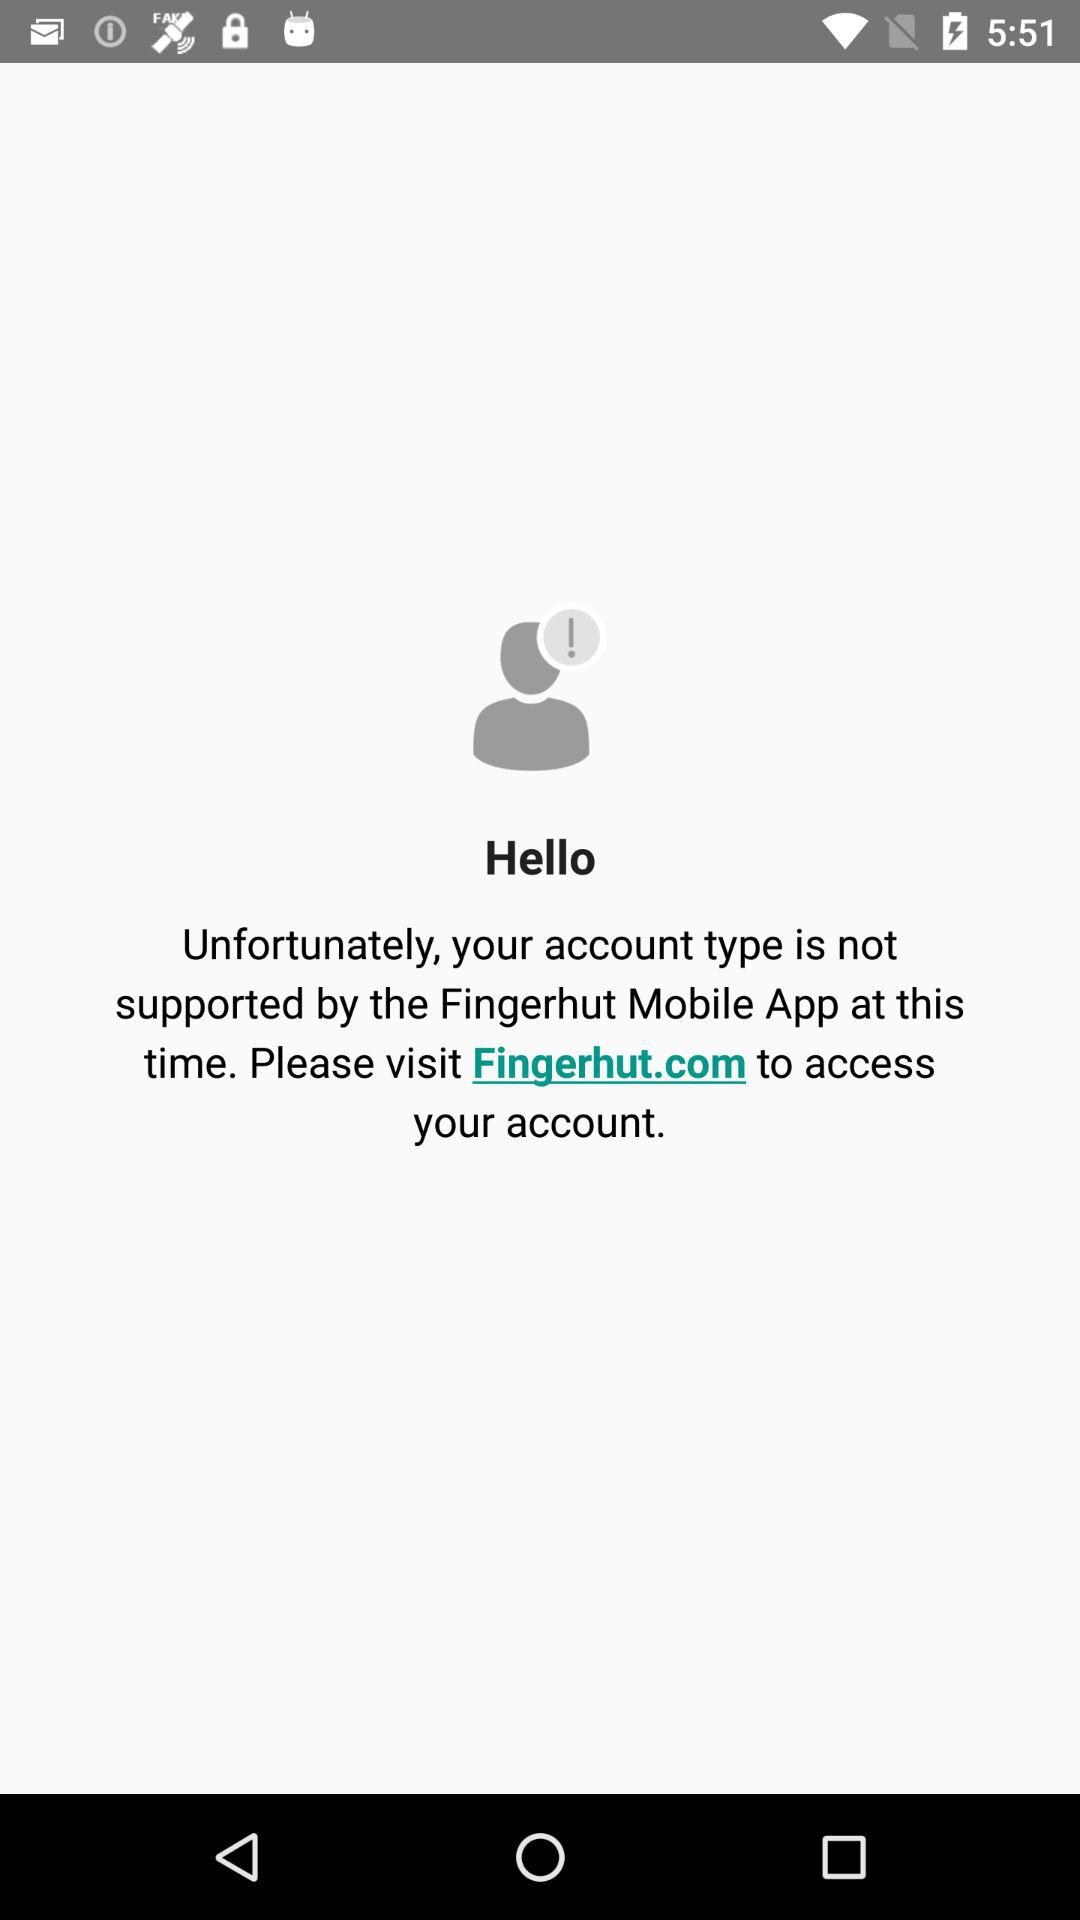What website should I go to to access my account? You should go to Fingerhut.com to access your account. 